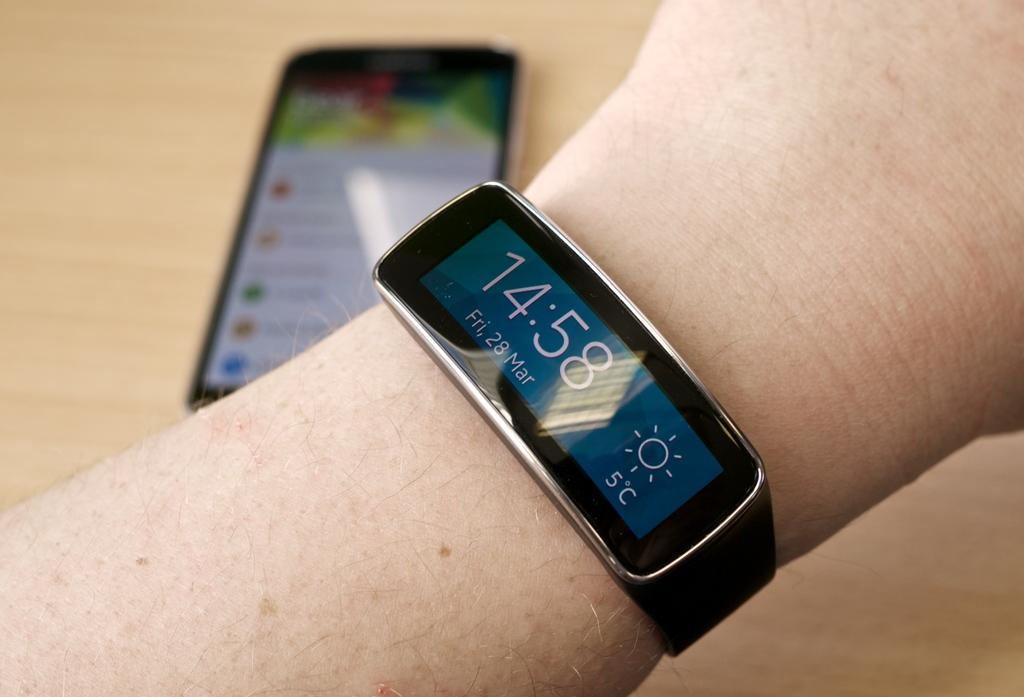<image>
Give a short and clear explanation of the subsequent image. Black smart watch displaying 14:58 as the time. 